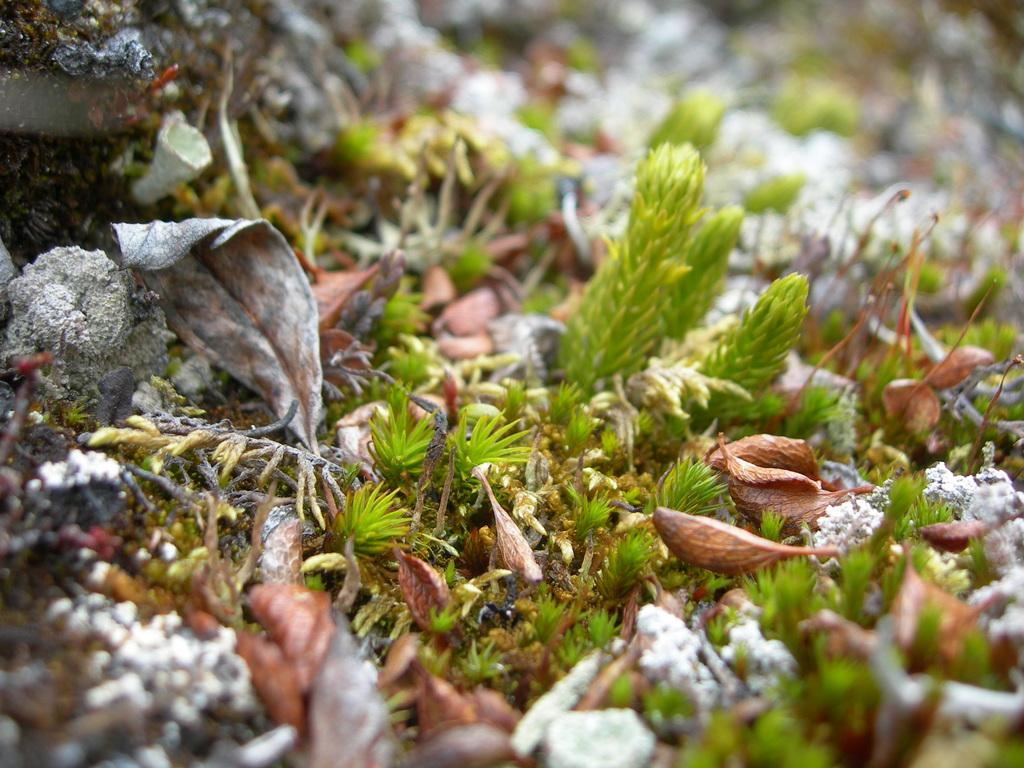What type of vegetation is present in the image? There is grass in the image. What can be seen on top of the grass? There are brown-colored things on the grass. How would you describe the overall clarity of the image? The image is slightly blurry. What type of secretary is visible in the image? There is no secretary present in the image. What list can be seen on the grass in the image? There is no list visible in the image. 